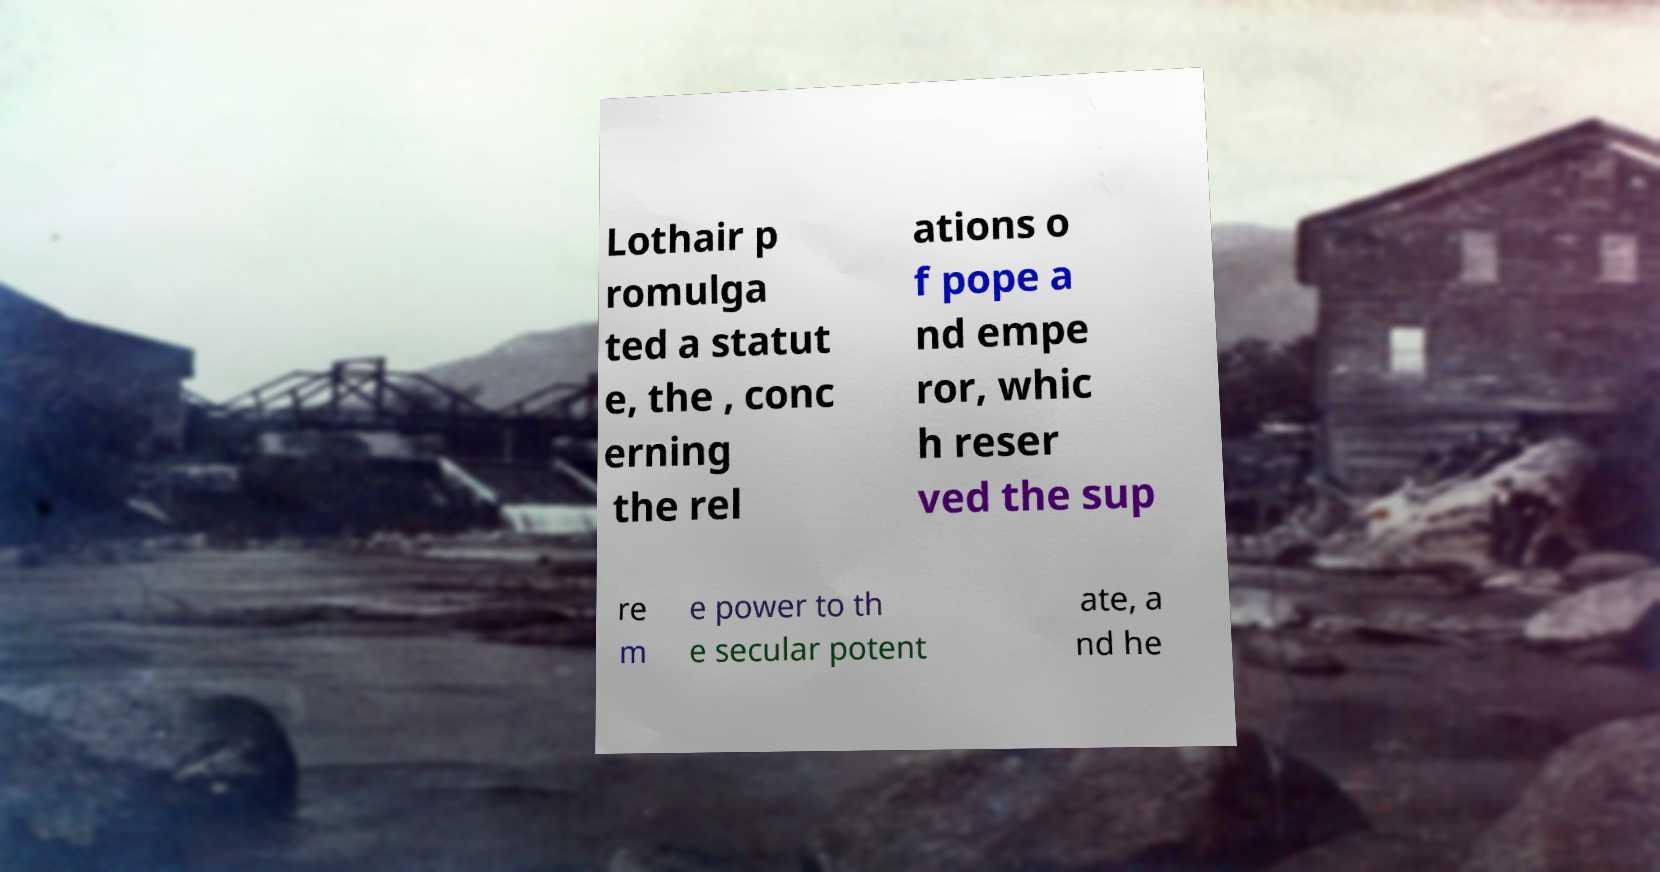Could you extract and type out the text from this image? Lothair p romulga ted a statut e, the , conc erning the rel ations o f pope a nd empe ror, whic h reser ved the sup re m e power to th e secular potent ate, a nd he 